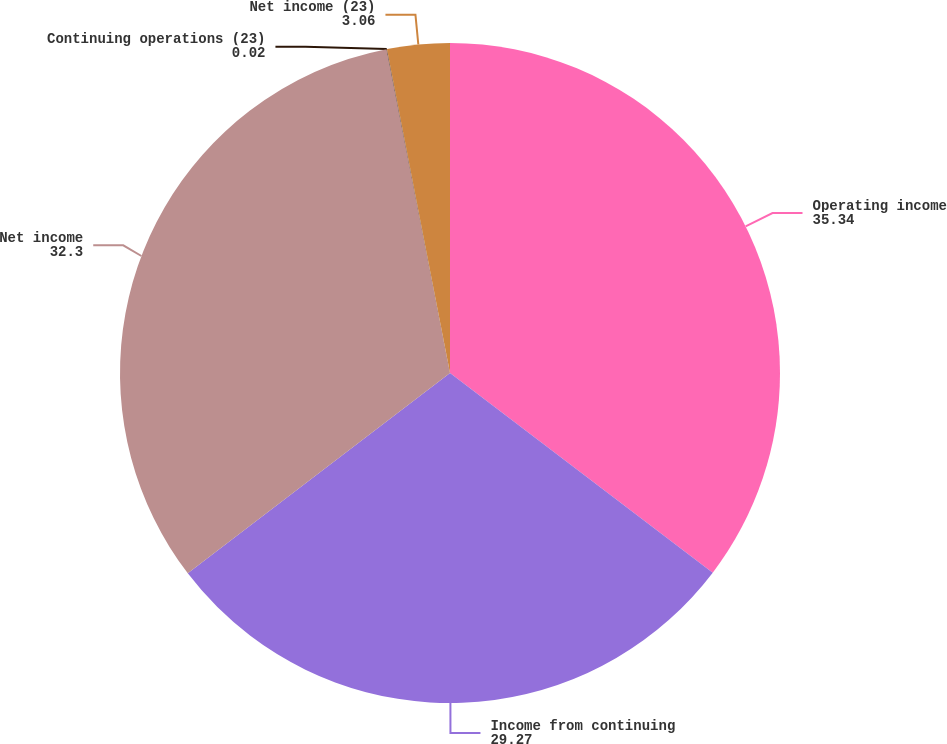Convert chart to OTSL. <chart><loc_0><loc_0><loc_500><loc_500><pie_chart><fcel>Operating income<fcel>Income from continuing<fcel>Net income<fcel>Continuing operations (23)<fcel>Net income (23)<nl><fcel>35.34%<fcel>29.27%<fcel>32.3%<fcel>0.02%<fcel>3.06%<nl></chart> 